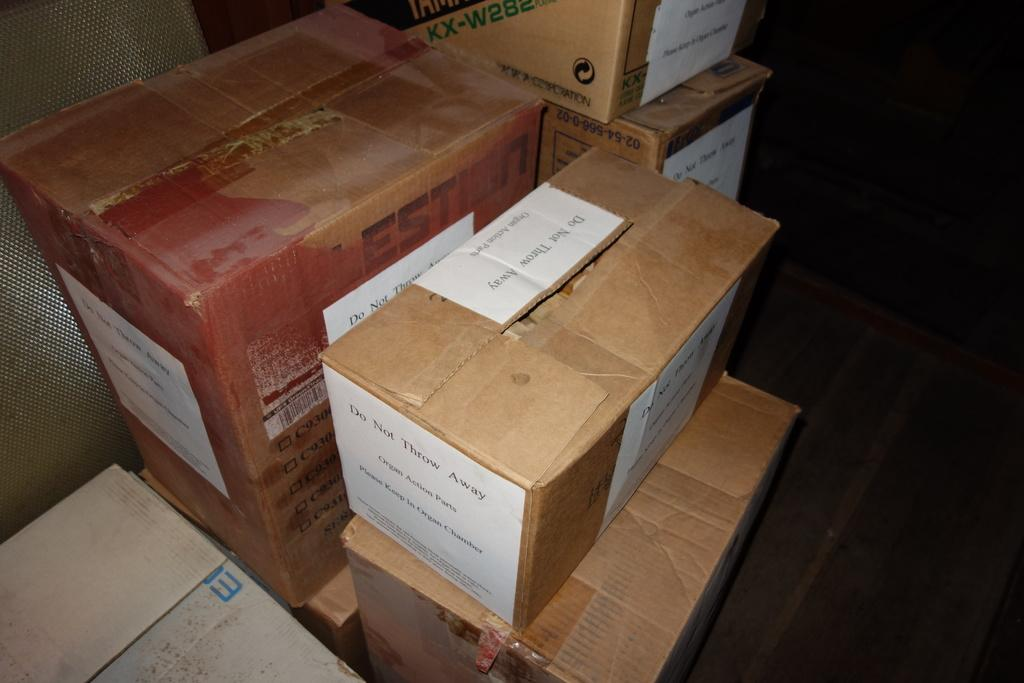<image>
Relay a brief, clear account of the picture shown. many card board boxes with one reading Do Not Throw Away 